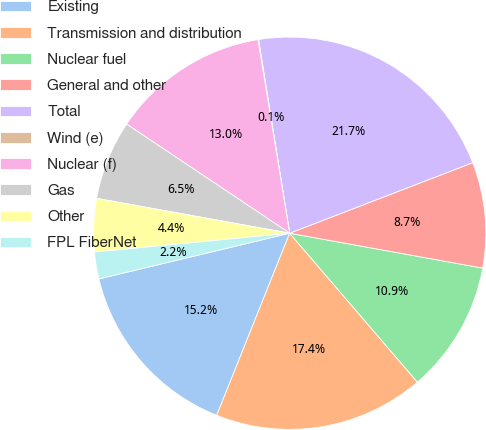Convert chart to OTSL. <chart><loc_0><loc_0><loc_500><loc_500><pie_chart><fcel>Existing<fcel>Transmission and distribution<fcel>Nuclear fuel<fcel>General and other<fcel>Total<fcel>Wind (e)<fcel>Nuclear (f)<fcel>Gas<fcel>Other<fcel>FPL FiberNet<nl><fcel>15.19%<fcel>17.35%<fcel>10.87%<fcel>8.7%<fcel>21.68%<fcel>0.05%<fcel>13.03%<fcel>6.54%<fcel>4.38%<fcel>2.21%<nl></chart> 